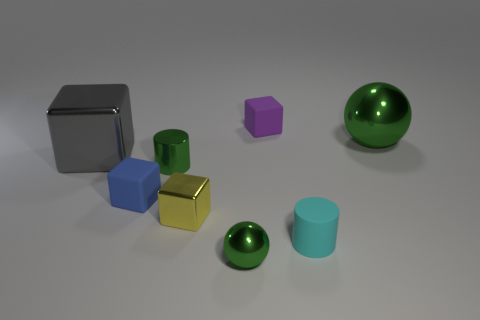Subtract 1 blocks. How many blocks are left? 3 Subtract all red cubes. Subtract all gray balls. How many cubes are left? 4 Add 2 tiny purple matte blocks. How many objects exist? 10 Subtract all balls. How many objects are left? 6 Subtract all matte things. Subtract all yellow blocks. How many objects are left? 4 Add 8 big green shiny objects. How many big green shiny objects are left? 9 Add 2 large gray metallic things. How many large gray metallic things exist? 3 Subtract 1 cyan cylinders. How many objects are left? 7 